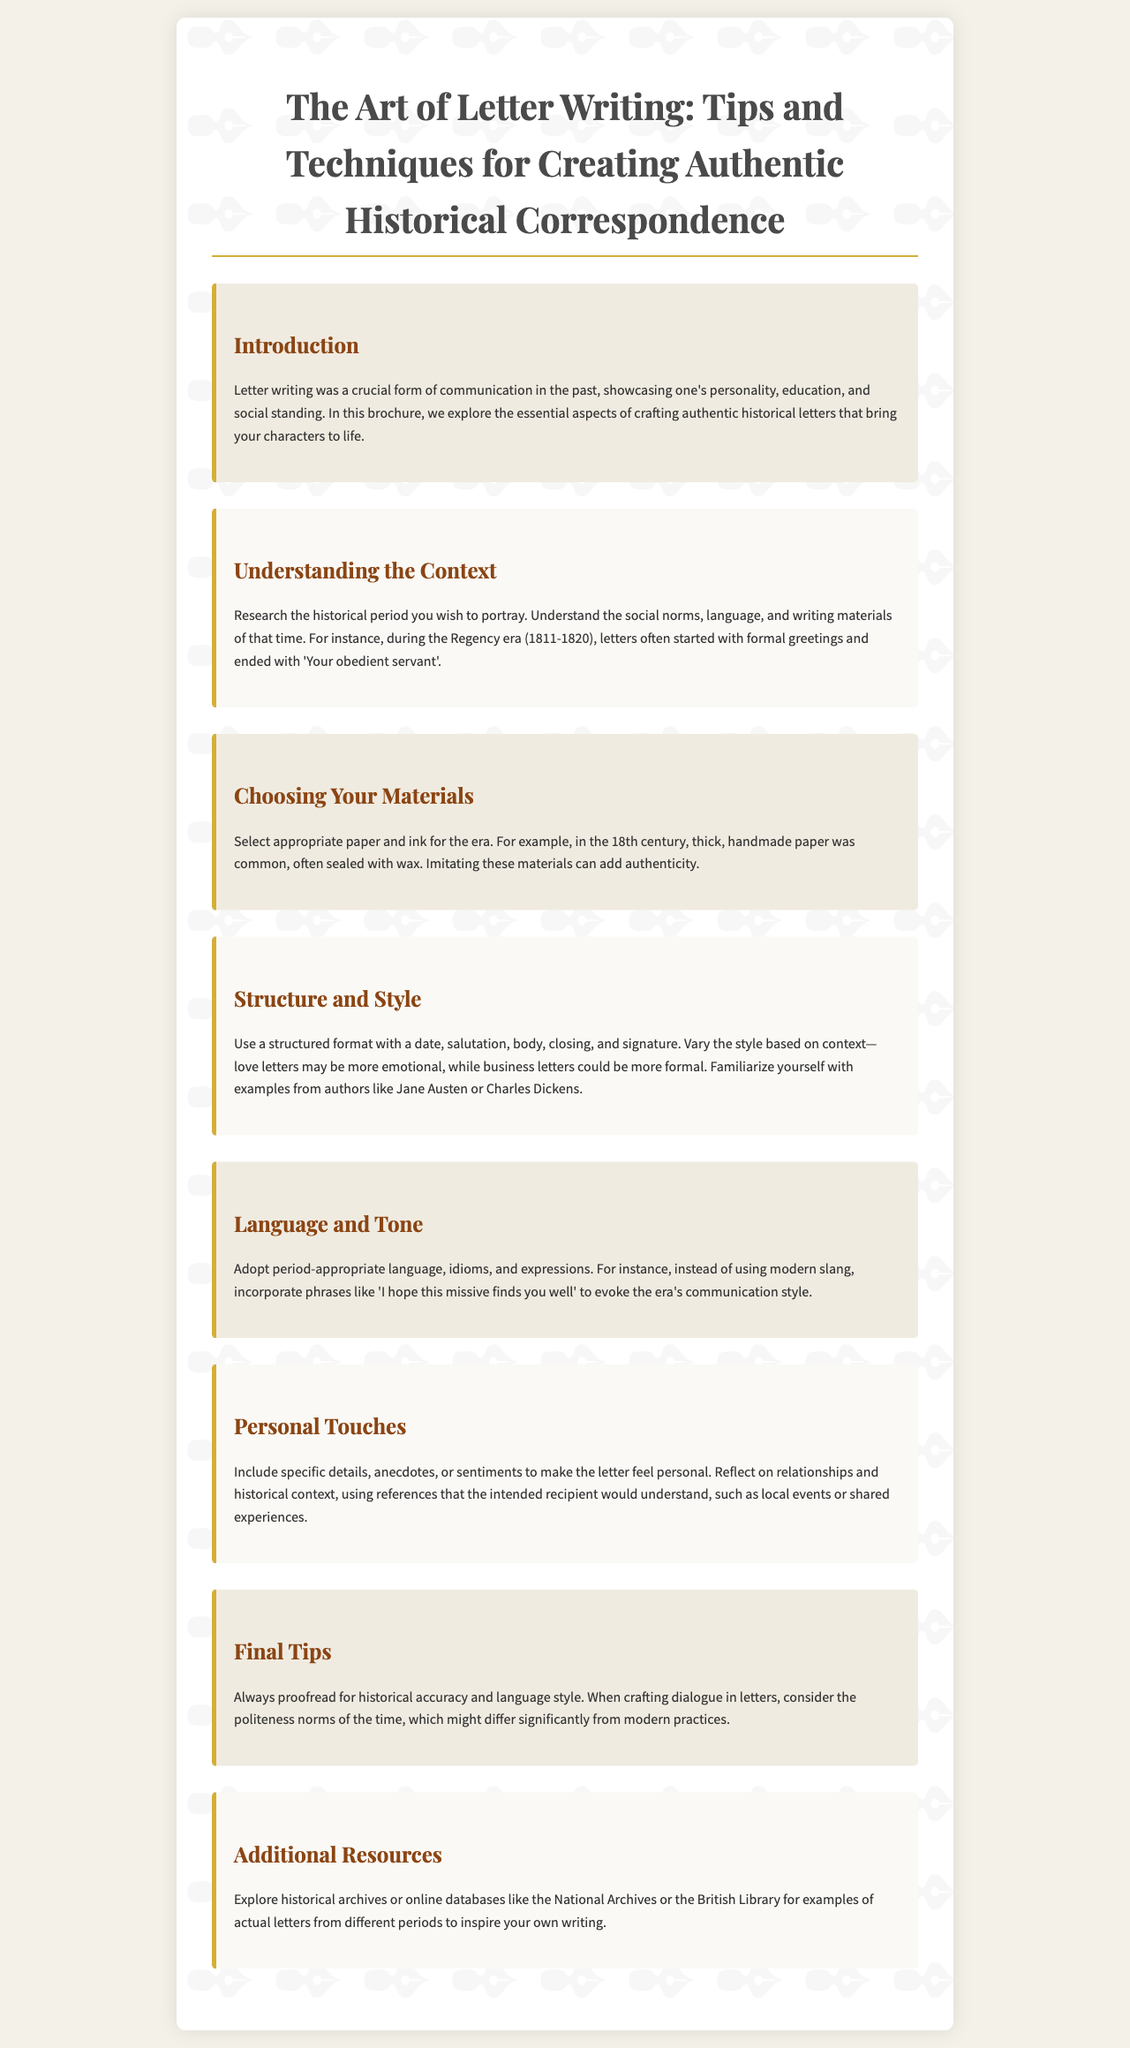What is the title of the brochure? The title is stated prominently at the top of the document.
Answer: The Art of Letter Writing: Tips and Techniques for Creating Authentic Historical Correspondence What is one historical period mentioned for understanding letter writing? The document specifically references a historical period in the context of letter writing.
Answer: Regency era What material is suggested for letters in the 18th century? The document describes the types of materials used in that century.
Answer: Handmade paper What should be included in the structure of a letter? The document lists components that should make up a letter's structure.
Answer: Date, salutation, body, closing, and signature What is a suggested phrase to evoke the era's communication style? The document provides an example of period-appropriate language.
Answer: I hope this missive finds you well What is a key personal touch to include in letters? The document emphasizes the importance of specific elements in making a letter personal.
Answer: Specific details What should you always do before finalizing a letter? The document advises on a practice to ensure quality and accuracy in letters.
Answer: Proofread What type of archives does the brochure suggest for inspiration? The document recommends sources for historical references.
Answer: National Archives 